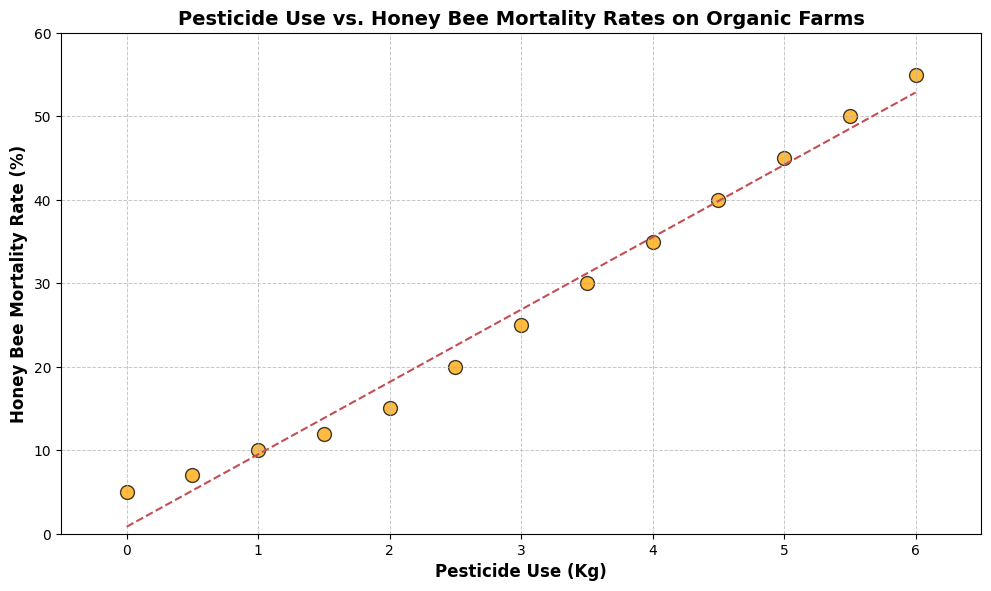What is the range of pesticide use values represented in the scatter plot? The range of pesticide use values is determined by finding the difference between the maximum and minimum values in the dataset. The maximum value for pesticide use is 6 kg, and the minimum value is 0 kg, so the range is 6 - 0 = 6 kg
Answer: 6 kg How does bee mortality rate change with increasing pesticide use? Observing the scatter plot, it is evident that the honey bee mortality rate increases as pesticide use increases. This is indicated by the upward trend in the data points and is confirmed by the trend line in the plot.
Answer: Increases What is the honey bee mortality rate when pesticide use is 2 kg? Locate the data point corresponding to 2 kg of pesticide use on the x-axis and identify the associated y-coordinate, which is the honey bee mortality rate. The y-coordinate for 2 kg of pesticide use is 15%.
Answer: 15% Is there any pesticide use level where the honey bee mortality rate is consistently below 10%? Identify the data points where the honey bee mortality rate is below 10%. The only data points with a mortality rate below 10% are at pesticide use levels of 0 and 0.5 kg, where the rates are 5% and 7%, respectively.
Answer: Yes, 0 and 0.5 kg By how much does the honey bee mortality rate increase on average per kg of pesticide use? Using the trend line, which represents the best fit line, the slope of the line indicates the average increase in bee mortality rate per kg of pesticide use. The trend line is given by the equation of the form y = mx + b, where m is the slope. Based on the plot, the slope is approximately 8.33. Therefore, the mortality rate increases by approximately 8.33% per kg of pesticide use on average.
Answer: 8.33% What can you infer about pesticide use and bee mortality if no pesticides are used? At 0 kg of pesticide use, the honey bee mortality rate is observed at 5% in the scatter plot. This suggests that without pesticide use, the bee mortality rate is relatively low.
Answer: Honey bee mortality is low Which data point has the highest honey bee mortality rate, and what is that rate? Identify the data point with the highest y-value on the scatter plot. The highest y-value corresponds to a mortality rate of 55% at a pesticide use level of 6 kg.
Answer: 6 kg, 55% How does the trend line help in understanding the relationship between pesticide use and honey bee mortality rate? The trend line in the scatter plot indicates the general direction and strength of the relationship between pesticide use and honey bee mortality rate. The positive slope of the trend line signifies that as pesticide use increases, the honey bee mortality rate also increases.
Answer: Indicates positive correlation 